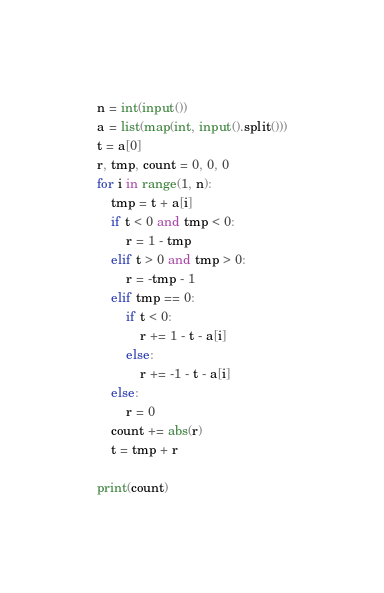<code> <loc_0><loc_0><loc_500><loc_500><_Python_>n = int(input())
a = list(map(int, input().split()))
t = a[0]
r, tmp, count = 0, 0, 0
for i in range(1, n):
    tmp = t + a[i]
    if t < 0 and tmp < 0:
        r = 1 - tmp
    elif t > 0 and tmp > 0:
        r = -tmp - 1
    elif tmp == 0:
        if t < 0:
            r += 1 - t - a[i]
        else:
            r += -1 - t - a[i]
    else:
        r = 0
    count += abs(r)
    t = tmp + r

print(count)</code> 